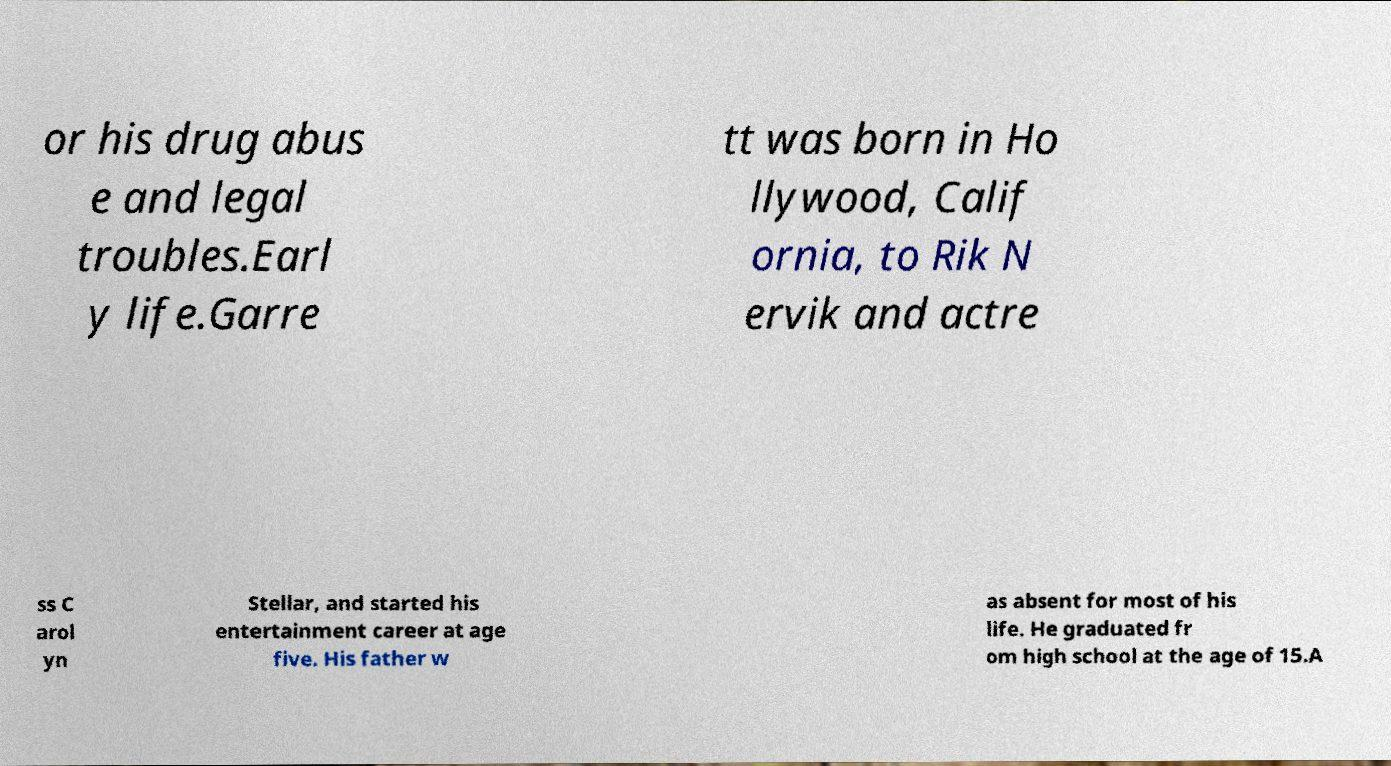Could you extract and type out the text from this image? or his drug abus e and legal troubles.Earl y life.Garre tt was born in Ho llywood, Calif ornia, to Rik N ervik and actre ss C arol yn Stellar, and started his entertainment career at age five. His father w as absent for most of his life. He graduated fr om high school at the age of 15.A 